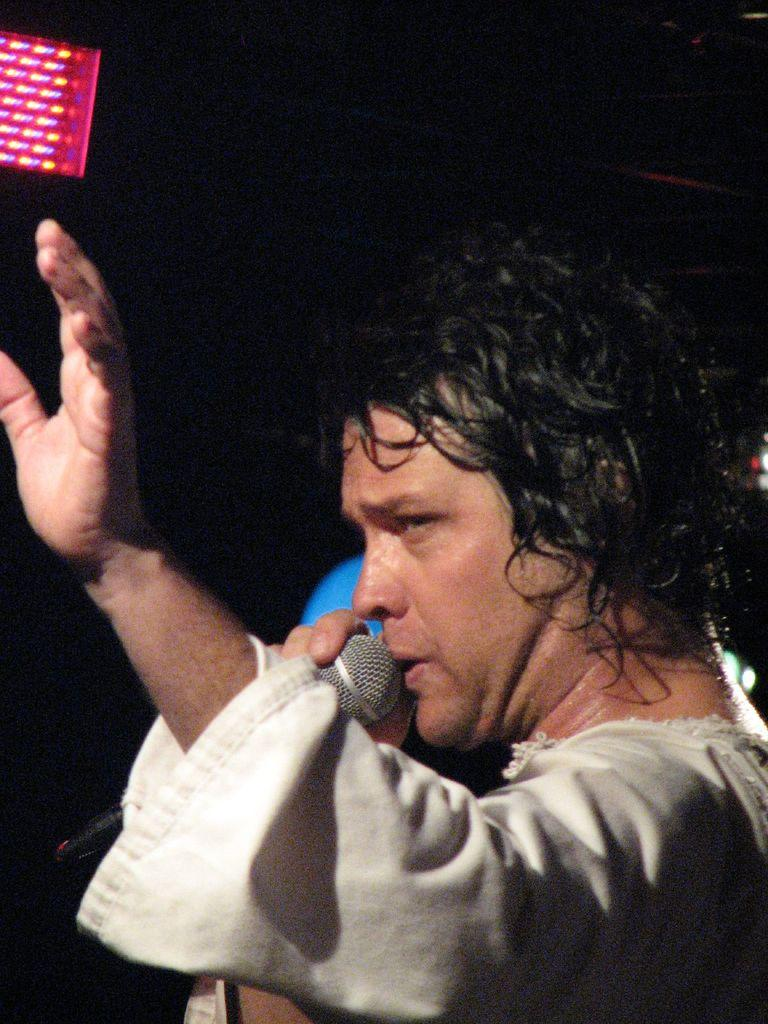Who is the main subject in the image? There is a man in the image. What is the man holding in the image? The man is holding a microphone. What can be seen on the left side of the image? There is a light on the left side of the image. How would you describe the overall lighting in the image? The background of the image is dark. How many matches are visible in the image? There are no matches present in the image. What limit is being tested in the image? There is no indication of a limit being tested in the image. 